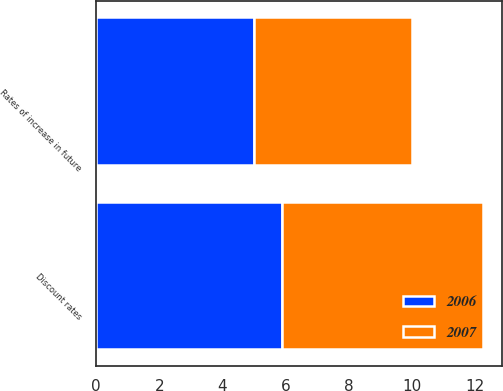<chart> <loc_0><loc_0><loc_500><loc_500><stacked_bar_chart><ecel><fcel>Discount rates<fcel>Rates of increase in future<nl><fcel>2007<fcel>6.38<fcel>5<nl><fcel>2006<fcel>5.88<fcel>5<nl></chart> 